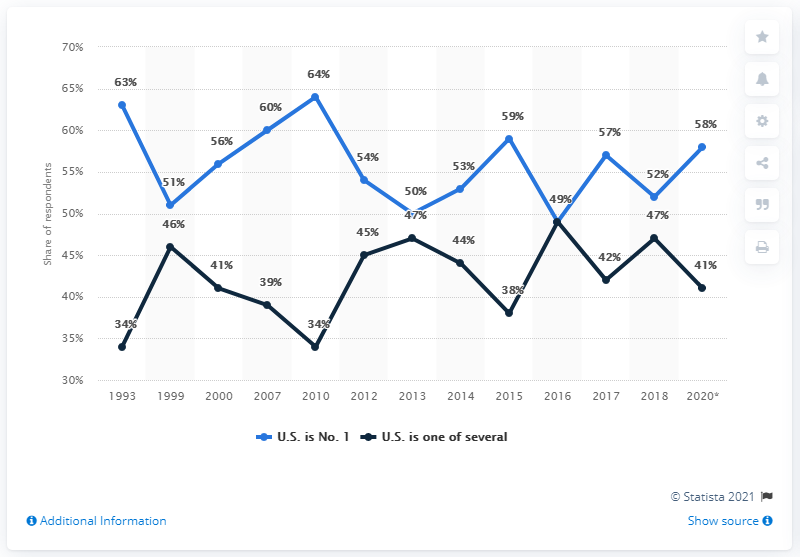Outline some significant characteristics in this image. The sum of the highest points on the black line and on the blue line is 113. The highest point in the blue line has a value of 64. 